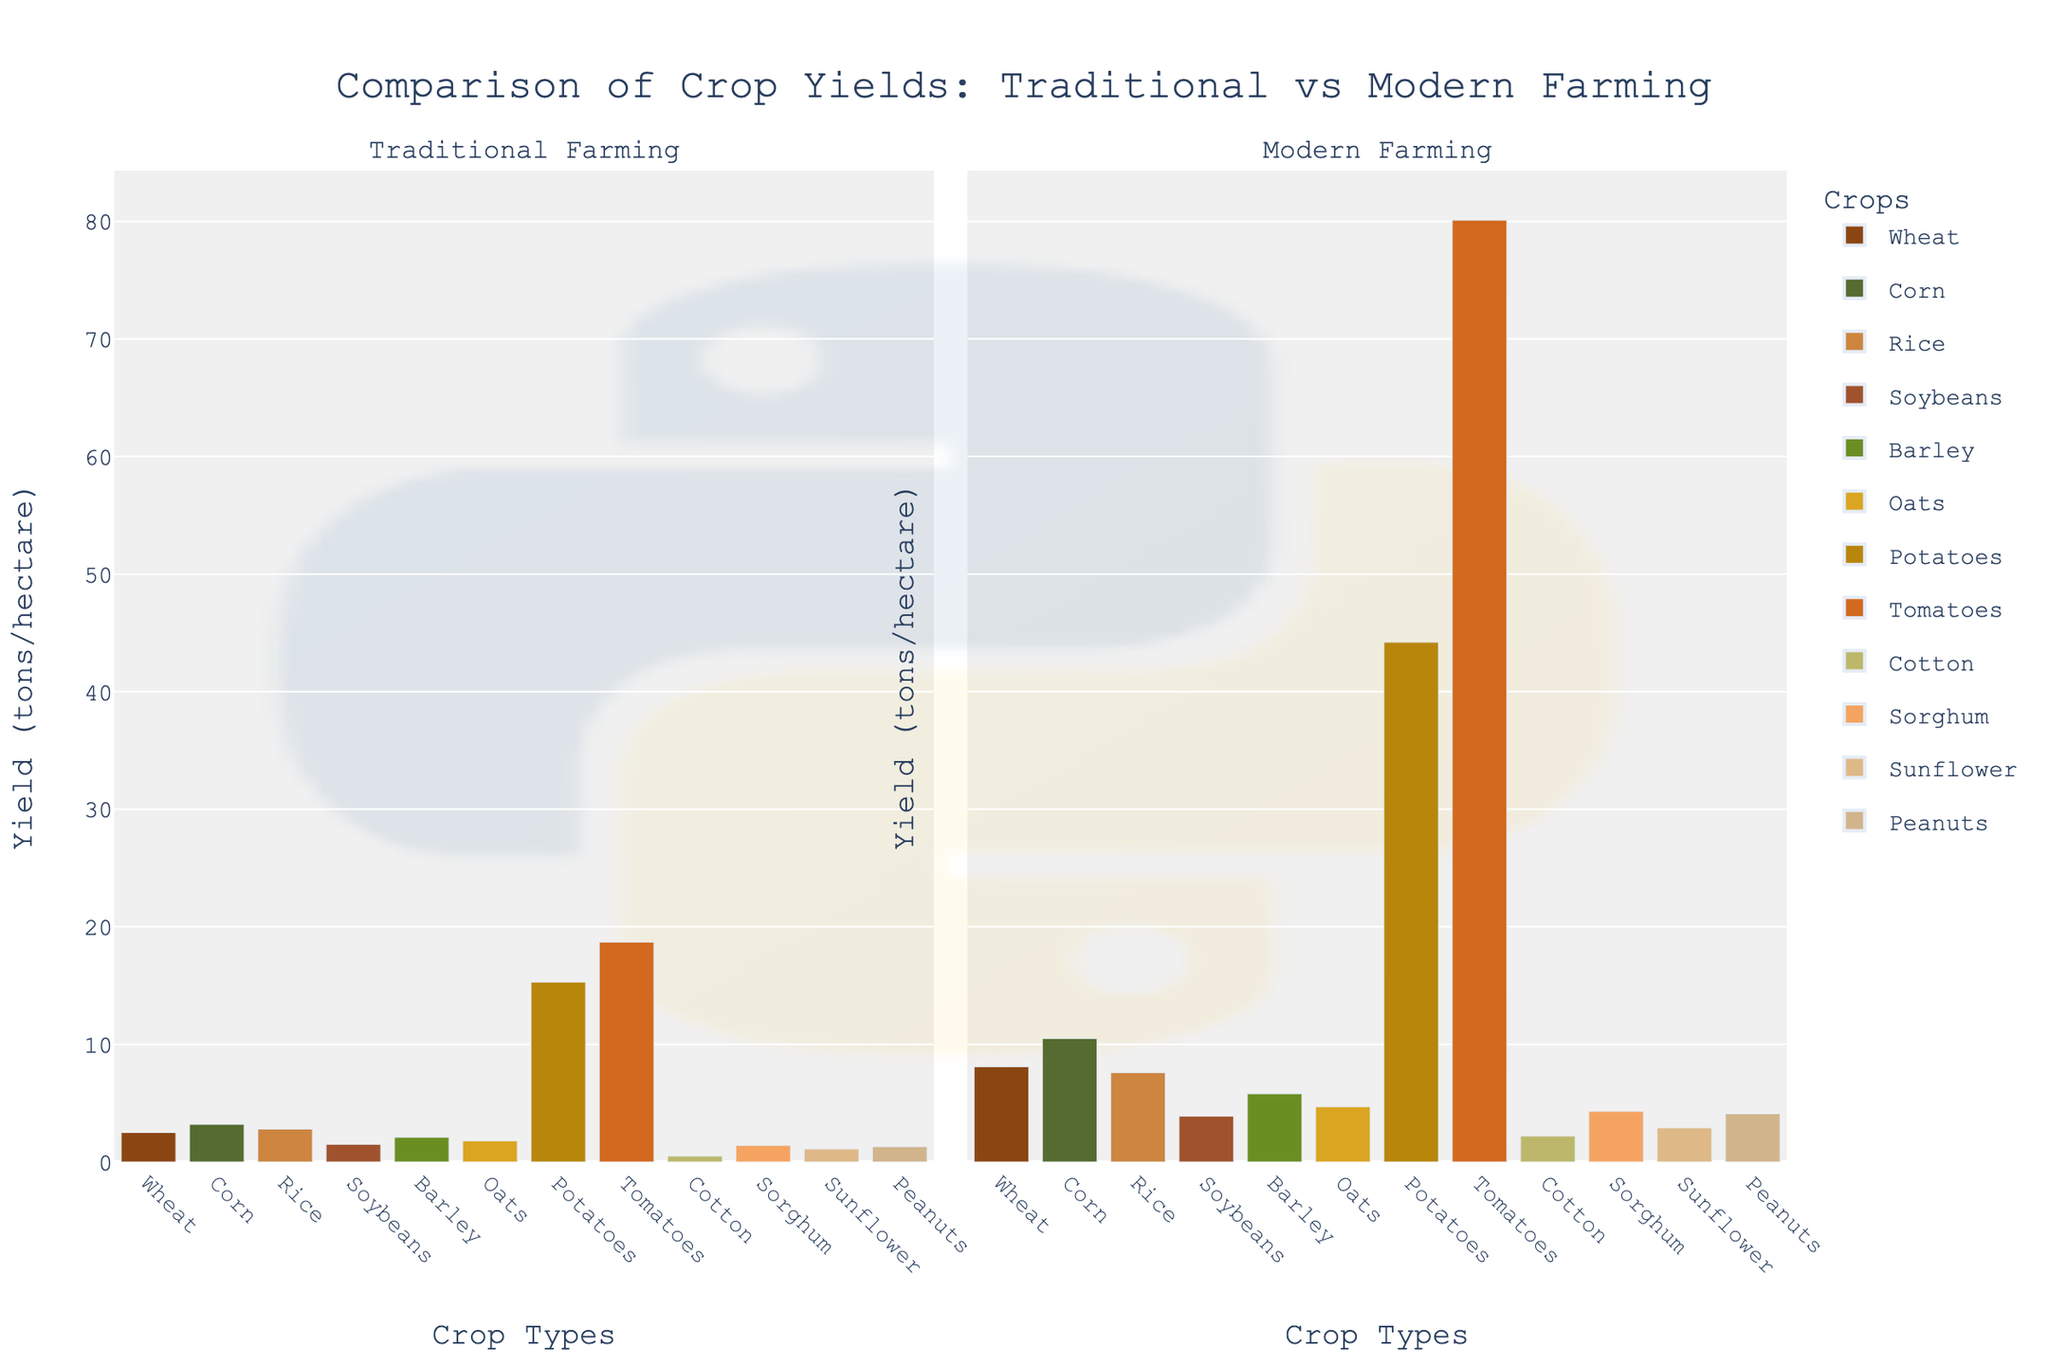What is the yield difference between traditional and modern farming methods for wheat? Refer to the bar heights for wheat in both traditional and modern farming. Traditional yield is 2.5 tons/hectare, and modern yield is 8.1 tons/hectare. The difference is calculated as 8.1 - 2.5.
Answer: 5.6 tons/hectare Which crop has the highest yield in modern farming methods? Check the bar heights in the modern farming subplot. Tomatoes have the highest yield with a bar height representing 80.1 tons/hectare.
Answer: Tomatoes What is the average yield for traditional farming across all crops? Sum the traditional yields for all crops and divide by the number of crops: (2.5 + 3.2 + 2.8 + 1.5 + 2.1 + 1.8 + 15.3 + 18.7 + 0.5 + 1.4 + 1.1 + 1.3) / 12. This equals 54.2 / 12.
Answer: 4.52 tons/hectare Which crop shows the greatest increase in yield from traditional to modern farming methods? Subtract the traditional yield from the modern yield for each crop and find the maximum difference: Tomatoes show the greatest increase with a difference of 80.1 - 18.7 = 61.4 tons/hectare.
Answer: Tomatoes Are there any crops where the yield is less than 2 tons/hectare in both farming methods? Check the bar heights in both subplots for values less than 2 tons/hectare. Only cotton has yields less than 2 tons/hectare in both methods, with 0.5 and 2.2 tons/hectare respectively.
Answer: No What is the ratio of modern yield to traditional yield for corn? Divide the modern yield by the traditional yield for corn: 10.5 / 3.2. This equals approximately 3.28.
Answer: 3.28 Compare the yields of potatoes in traditional and modern farming methods. Which is higher, and by how much? Refer to the bar heights for potatoes. The modern yield is 44.2 tons/hectare, and the traditional yield is 15.3 tons/hectare. The difference is 44.2 - 15.3.
Answer: Modern by 28.9 tons/hectare Which crop has the lowest yield in traditional farming methods and what is the value? Check the bar heights in the traditional farming subplot. Cotton has the lowest yield with 0.5 tons/hectare.
Answer: Cotton, 0.5 tons/hectare By how much does the yield of sorghum increase when switching from traditional to modern farming methods? Compare the bar heights for sorghum in both subplots. The modern yield is 4.3 tons/hectare and the traditional yield is 1.4 tons/hectare. The increase is 4.3 - 1.4.
Answer: 2.9 tons/hectare 